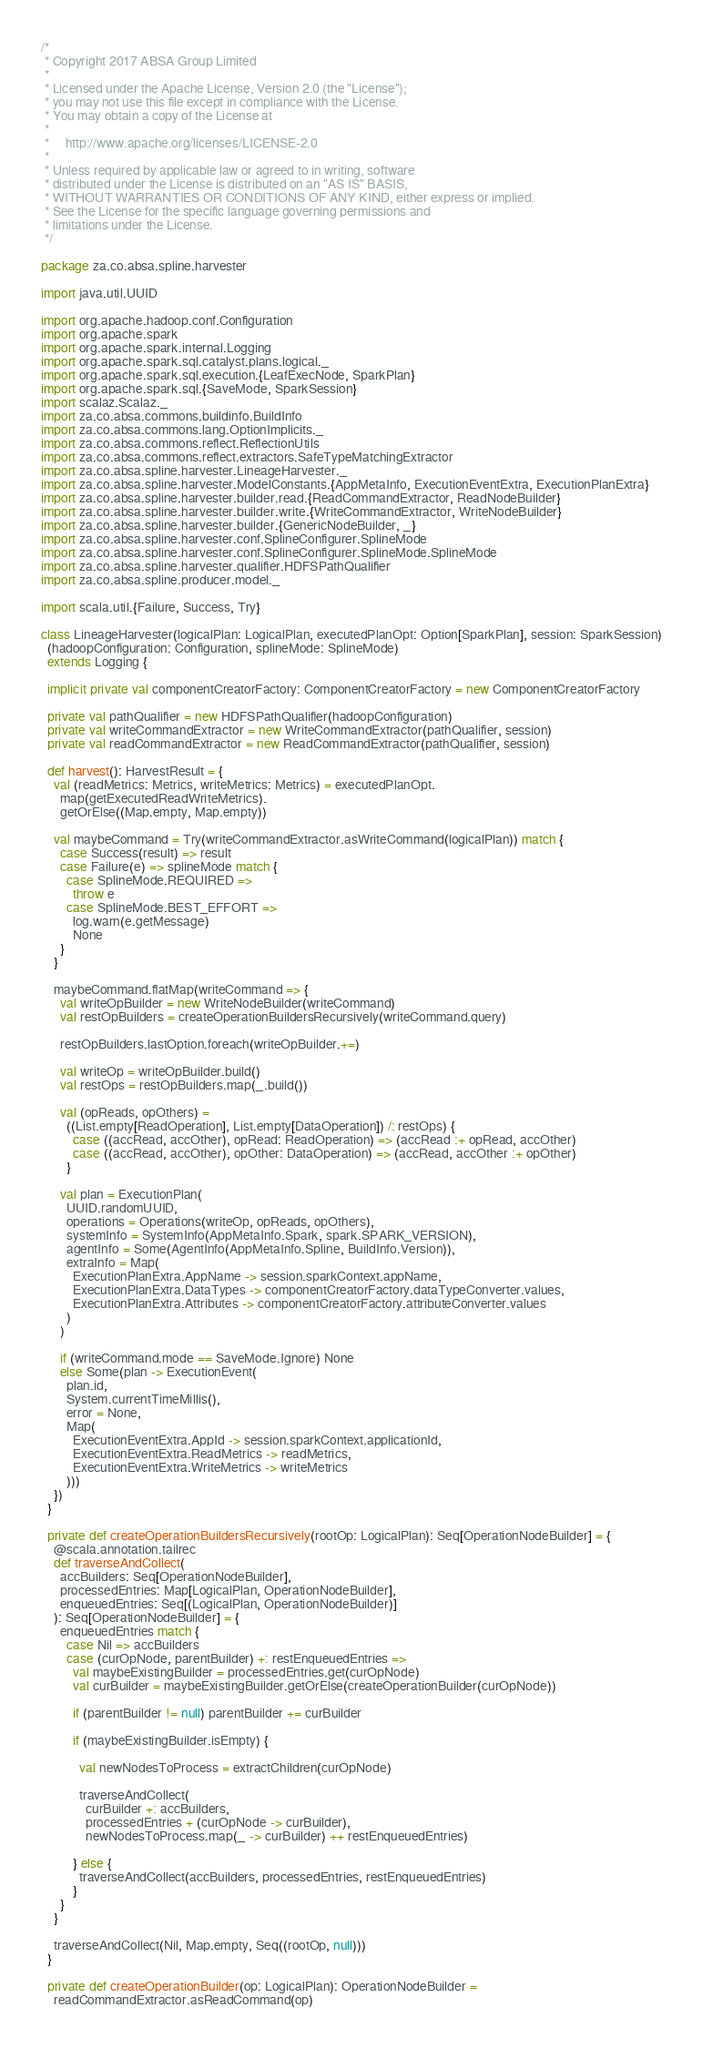Convert code to text. <code><loc_0><loc_0><loc_500><loc_500><_Scala_>/*
 * Copyright 2017 ABSA Group Limited
 *
 * Licensed under the Apache License, Version 2.0 (the "License");
 * you may not use this file except in compliance with the License.
 * You may obtain a copy of the License at
 *
 *     http://www.apache.org/licenses/LICENSE-2.0
 *
 * Unless required by applicable law or agreed to in writing, software
 * distributed under the License is distributed on an "AS IS" BASIS,
 * WITHOUT WARRANTIES OR CONDITIONS OF ANY KIND, either express or implied.
 * See the License for the specific language governing permissions and
 * limitations under the License.
 */

package za.co.absa.spline.harvester

import java.util.UUID

import org.apache.hadoop.conf.Configuration
import org.apache.spark
import org.apache.spark.internal.Logging
import org.apache.spark.sql.catalyst.plans.logical._
import org.apache.spark.sql.execution.{LeafExecNode, SparkPlan}
import org.apache.spark.sql.{SaveMode, SparkSession}
import scalaz.Scalaz._
import za.co.absa.commons.buildinfo.BuildInfo
import za.co.absa.commons.lang.OptionImplicits._
import za.co.absa.commons.reflect.ReflectionUtils
import za.co.absa.commons.reflect.extractors.SafeTypeMatchingExtractor
import za.co.absa.spline.harvester.LineageHarvester._
import za.co.absa.spline.harvester.ModelConstants.{AppMetaInfo, ExecutionEventExtra, ExecutionPlanExtra}
import za.co.absa.spline.harvester.builder.read.{ReadCommandExtractor, ReadNodeBuilder}
import za.co.absa.spline.harvester.builder.write.{WriteCommandExtractor, WriteNodeBuilder}
import za.co.absa.spline.harvester.builder.{GenericNodeBuilder, _}
import za.co.absa.spline.harvester.conf.SplineConfigurer.SplineMode
import za.co.absa.spline.harvester.conf.SplineConfigurer.SplineMode.SplineMode
import za.co.absa.spline.harvester.qualifier.HDFSPathQualifier
import za.co.absa.spline.producer.model._

import scala.util.{Failure, Success, Try}

class LineageHarvester(logicalPlan: LogicalPlan, executedPlanOpt: Option[SparkPlan], session: SparkSession)
  (hadoopConfiguration: Configuration, splineMode: SplineMode)
  extends Logging {

  implicit private val componentCreatorFactory: ComponentCreatorFactory = new ComponentCreatorFactory

  private val pathQualifier = new HDFSPathQualifier(hadoopConfiguration)
  private val writeCommandExtractor = new WriteCommandExtractor(pathQualifier, session)
  private val readCommandExtractor = new ReadCommandExtractor(pathQualifier, session)

  def harvest(): HarvestResult = {
    val (readMetrics: Metrics, writeMetrics: Metrics) = executedPlanOpt.
      map(getExecutedReadWriteMetrics).
      getOrElse((Map.empty, Map.empty))

    val maybeCommand = Try(writeCommandExtractor.asWriteCommand(logicalPlan)) match {
      case Success(result) => result
      case Failure(e) => splineMode match {
        case SplineMode.REQUIRED =>
          throw e
        case SplineMode.BEST_EFFORT =>
          log.warn(e.getMessage)
          None
      }
    }

    maybeCommand.flatMap(writeCommand => {
      val writeOpBuilder = new WriteNodeBuilder(writeCommand)
      val restOpBuilders = createOperationBuildersRecursively(writeCommand.query)

      restOpBuilders.lastOption.foreach(writeOpBuilder.+=)

      val writeOp = writeOpBuilder.build()
      val restOps = restOpBuilders.map(_.build())

      val (opReads, opOthers) =
        ((List.empty[ReadOperation], List.empty[DataOperation]) /: restOps) {
          case ((accRead, accOther), opRead: ReadOperation) => (accRead :+ opRead, accOther)
          case ((accRead, accOther), opOther: DataOperation) => (accRead, accOther :+ opOther)
        }

      val plan = ExecutionPlan(
        UUID.randomUUID,
        operations = Operations(writeOp, opReads, opOthers),
        systemInfo = SystemInfo(AppMetaInfo.Spark, spark.SPARK_VERSION),
        agentInfo = Some(AgentInfo(AppMetaInfo.Spline, BuildInfo.Version)),
        extraInfo = Map(
          ExecutionPlanExtra.AppName -> session.sparkContext.appName,
          ExecutionPlanExtra.DataTypes -> componentCreatorFactory.dataTypeConverter.values,
          ExecutionPlanExtra.Attributes -> componentCreatorFactory.attributeConverter.values
        )
      )

      if (writeCommand.mode == SaveMode.Ignore) None
      else Some(plan -> ExecutionEvent(
        plan.id,
        System.currentTimeMillis(),
        error = None,
        Map(
          ExecutionEventExtra.AppId -> session.sparkContext.applicationId,
          ExecutionEventExtra.ReadMetrics -> readMetrics,
          ExecutionEventExtra.WriteMetrics -> writeMetrics
        )))
    })
  }

  private def createOperationBuildersRecursively(rootOp: LogicalPlan): Seq[OperationNodeBuilder] = {
    @scala.annotation.tailrec
    def traverseAndCollect(
      accBuilders: Seq[OperationNodeBuilder],
      processedEntries: Map[LogicalPlan, OperationNodeBuilder],
      enqueuedEntries: Seq[(LogicalPlan, OperationNodeBuilder)]
    ): Seq[OperationNodeBuilder] = {
      enqueuedEntries match {
        case Nil => accBuilders
        case (curOpNode, parentBuilder) +: restEnqueuedEntries =>
          val maybeExistingBuilder = processedEntries.get(curOpNode)
          val curBuilder = maybeExistingBuilder.getOrElse(createOperationBuilder(curOpNode))

          if (parentBuilder != null) parentBuilder += curBuilder

          if (maybeExistingBuilder.isEmpty) {

            val newNodesToProcess = extractChildren(curOpNode)

            traverseAndCollect(
              curBuilder +: accBuilders,
              processedEntries + (curOpNode -> curBuilder),
              newNodesToProcess.map(_ -> curBuilder) ++ restEnqueuedEntries)

          } else {
            traverseAndCollect(accBuilders, processedEntries, restEnqueuedEntries)
          }
      }
    }

    traverseAndCollect(Nil, Map.empty, Seq((rootOp, null)))
  }

  private def createOperationBuilder(op: LogicalPlan): OperationNodeBuilder =
    readCommandExtractor.asReadCommand(op)</code> 